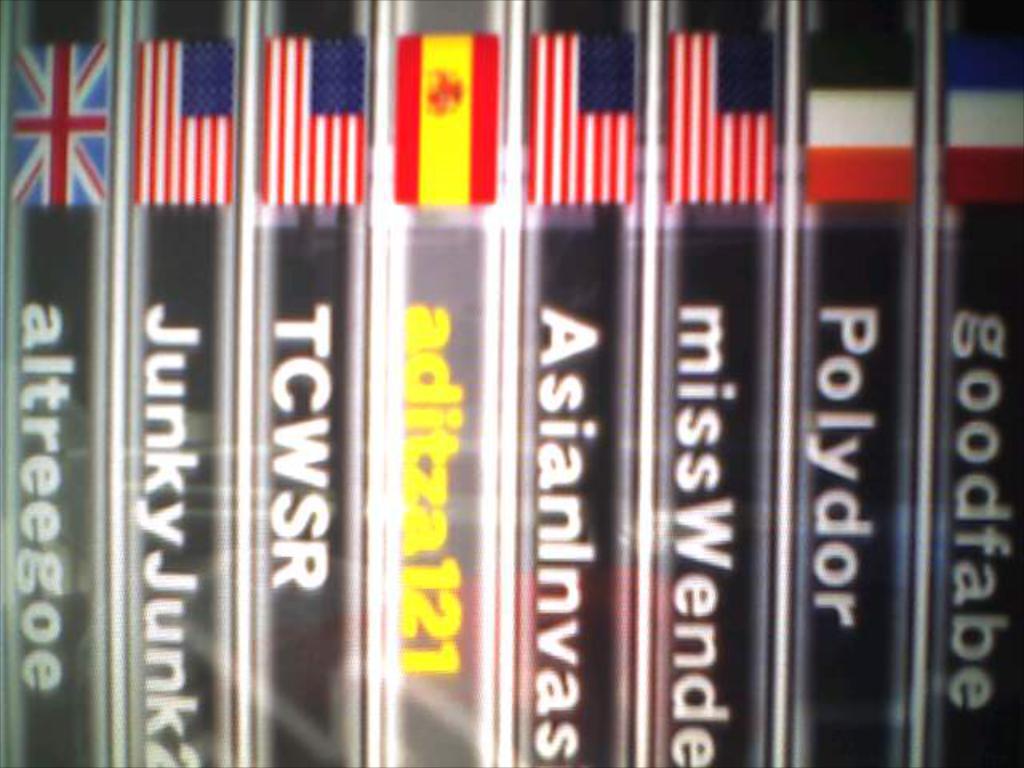What is the name of the third tape?
Make the answer very short. Tcwsr. What is the word on the first tape to the right?
Your answer should be compact. Goodfabe. 